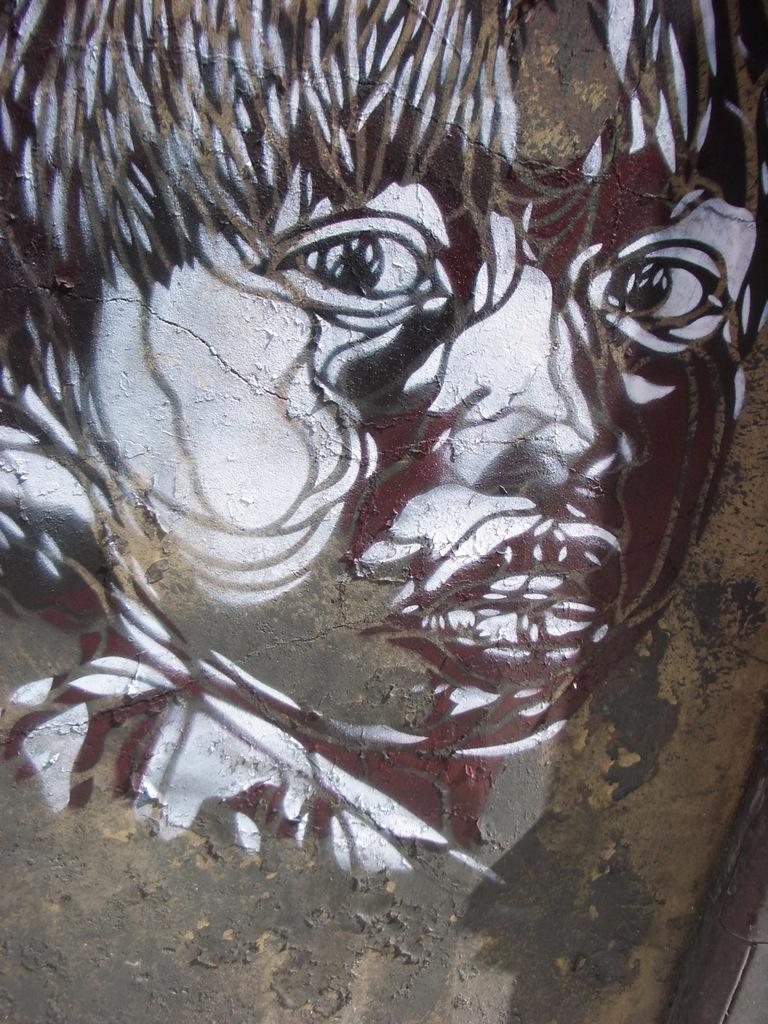How would you summarize this image in a sentence or two? Here we can see painting of a person face on the surface. 